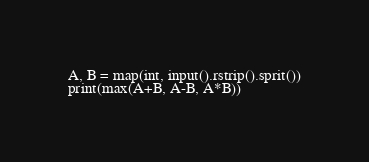Convert code to text. <code><loc_0><loc_0><loc_500><loc_500><_Python_>A, B = map(int, input().rstrip().sprit())
print(max(A+B, A-B, A*B))</code> 